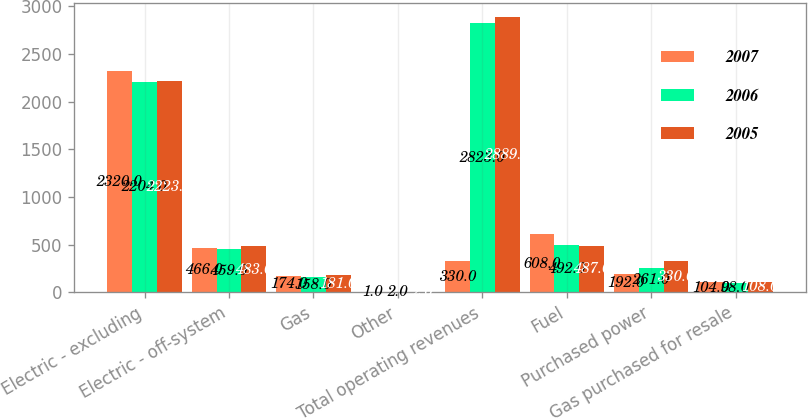Convert chart. <chart><loc_0><loc_0><loc_500><loc_500><stacked_bar_chart><ecel><fcel>Electric - excluding<fcel>Electric - off-system<fcel>Gas<fcel>Other<fcel>Total operating revenues<fcel>Fuel<fcel>Purchased power<fcel>Gas purchased for resale<nl><fcel>2007<fcel>2320<fcel>466<fcel>174<fcel>1<fcel>330<fcel>608<fcel>192<fcel>104<nl><fcel>2006<fcel>2204<fcel>459<fcel>158<fcel>2<fcel>2823<fcel>492<fcel>261<fcel>98<nl><fcel>2005<fcel>2223<fcel>483<fcel>181<fcel>2<fcel>2889<fcel>487<fcel>330<fcel>108<nl></chart> 